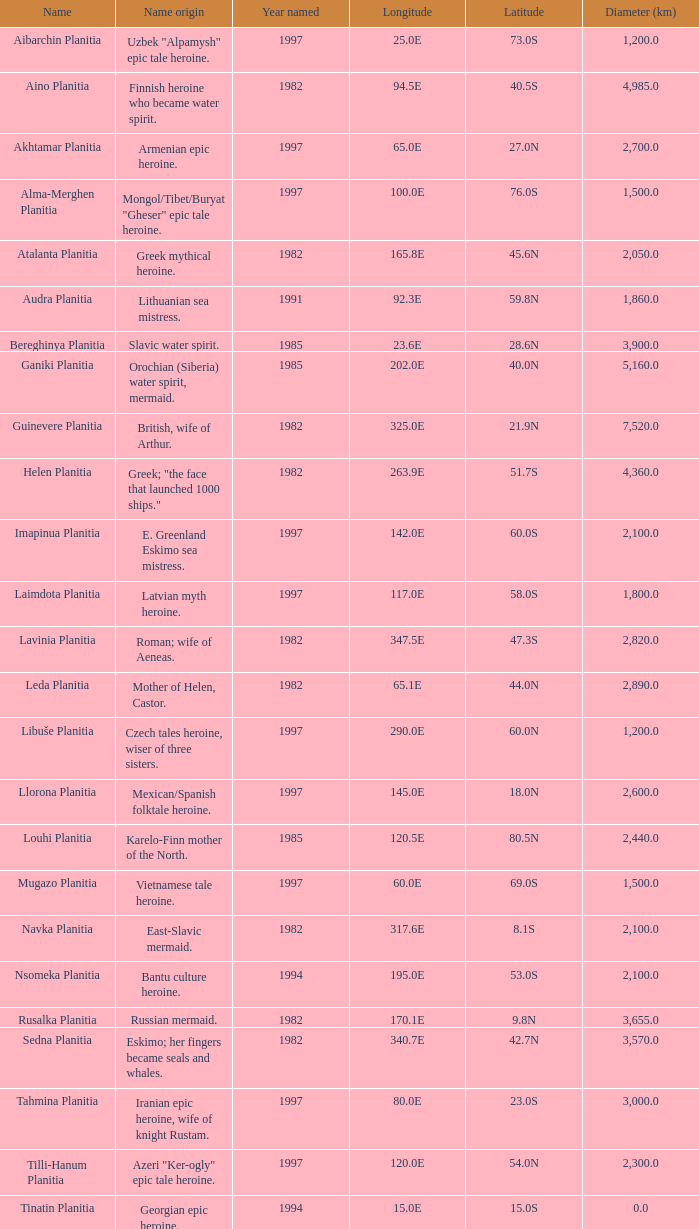What's the name origin of feature of diameter (km) 2,155.0 Karelo-Finn mermaid. 